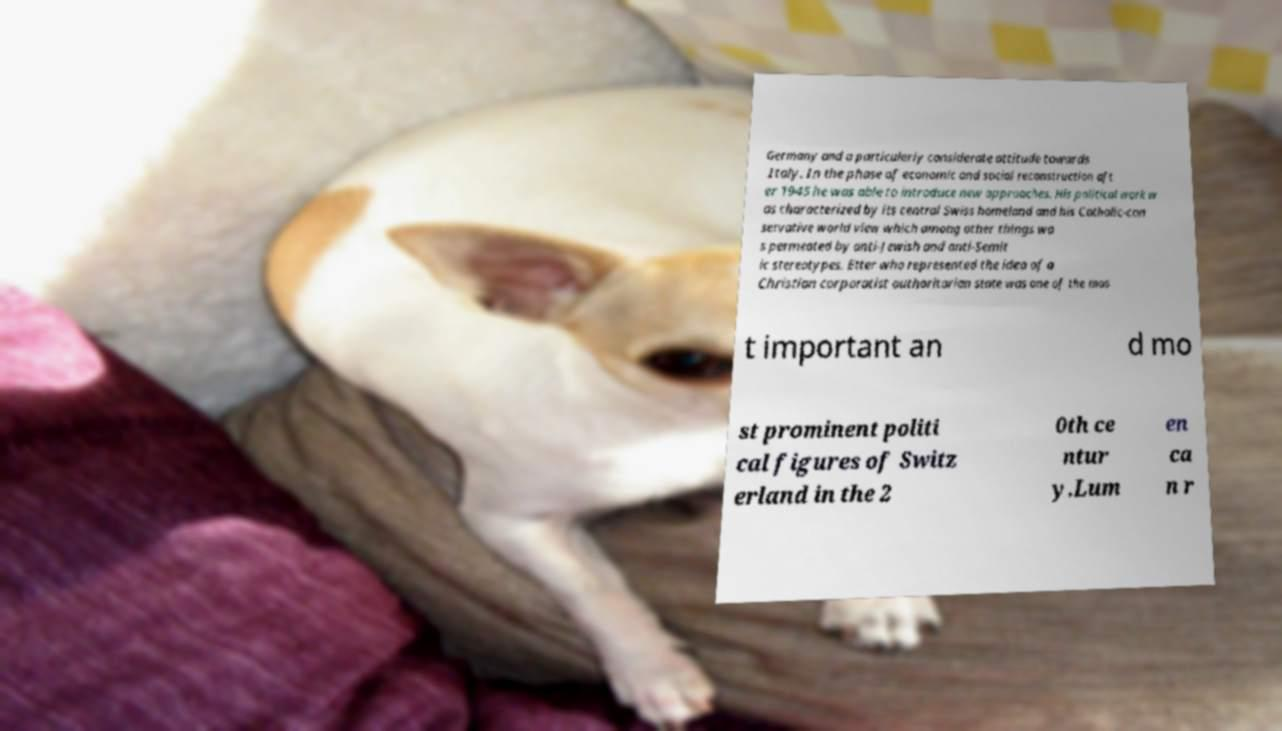What messages or text are displayed in this image? I need them in a readable, typed format. Germany and a particularly considerate attitude towards Italy. In the phase of economic and social reconstruction aft er 1945 he was able to introduce new approaches. His political work w as characterized by its central Swiss homeland and his Catholic-con servative world view which among other things wa s permeated by anti-Jewish and anti-Semit ic stereotypes. Etter who represented the idea of a Christian corporatist authoritarian state was one of the mos t important an d mo st prominent politi cal figures of Switz erland in the 2 0th ce ntur y.Lum en ca n r 